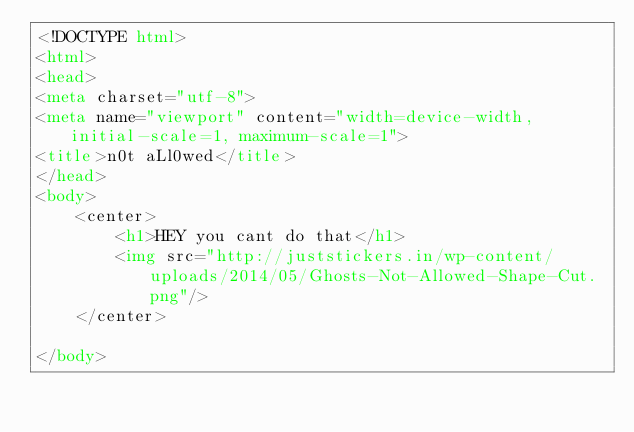Convert code to text. <code><loc_0><loc_0><loc_500><loc_500><_HTML_><!DOCTYPE html>
<html>
<head>
<meta charset="utf-8">
<meta name="viewport" content="width=device-width, initial-scale=1, maximum-scale=1">
<title>n0t aLl0wed</title>
</head>
<body>
	<center>
		<h1>HEY you cant do that</h1>
		<img src="http://juststickers.in/wp-content/uploads/2014/05/Ghosts-Not-Allowed-Shape-Cut.png"/>
	</center>

</body>
</code> 